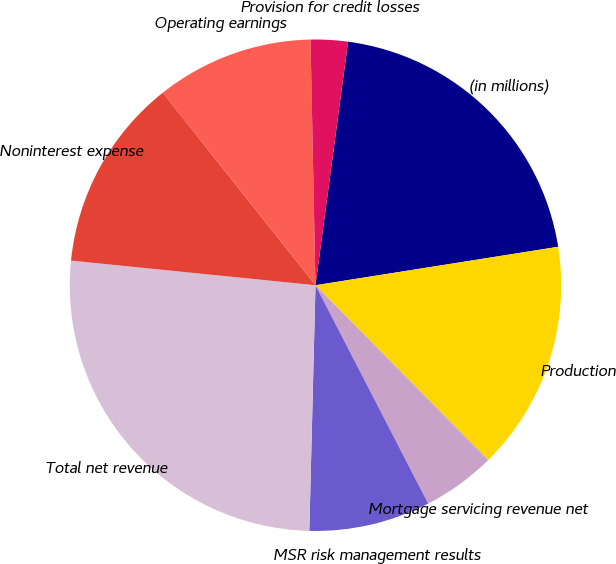<chart> <loc_0><loc_0><loc_500><loc_500><pie_chart><fcel>(in millions)<fcel>Production<fcel>Mortgage servicing revenue net<fcel>MSR risk management results<fcel>Total net revenue<fcel>Noninterest expense<fcel>Operating earnings<fcel>Provision for credit losses<nl><fcel>20.38%<fcel>15.1%<fcel>4.82%<fcel>7.98%<fcel>26.2%<fcel>12.73%<fcel>10.35%<fcel>2.44%<nl></chart> 